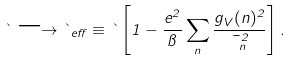<formula> <loc_0><loc_0><loc_500><loc_500>\theta \longrightarrow \theta _ { e f f } \equiv \theta \left [ 1 - \frac { e ^ { 2 } } { \pi } \sum _ { n } \frac { g _ { V } ( n ) ^ { 2 } } { \mu _ { n } ^ { 2 } } \right ] .</formula> 